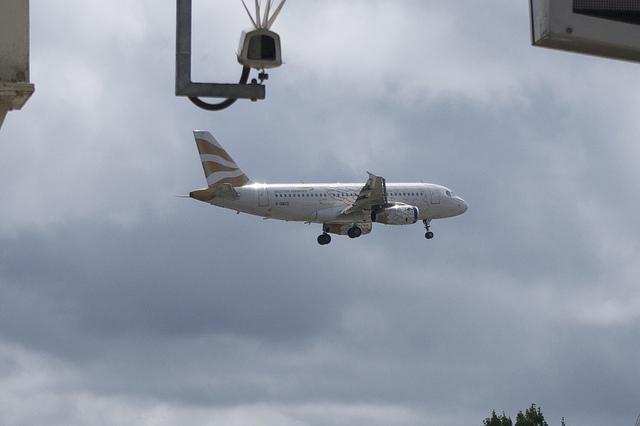Is the plane landing?
Quick response, please. Yes. Are the plane's wheels up or down?
Short answer required. Down. What is the plane doing?
Answer briefly. Flying. 